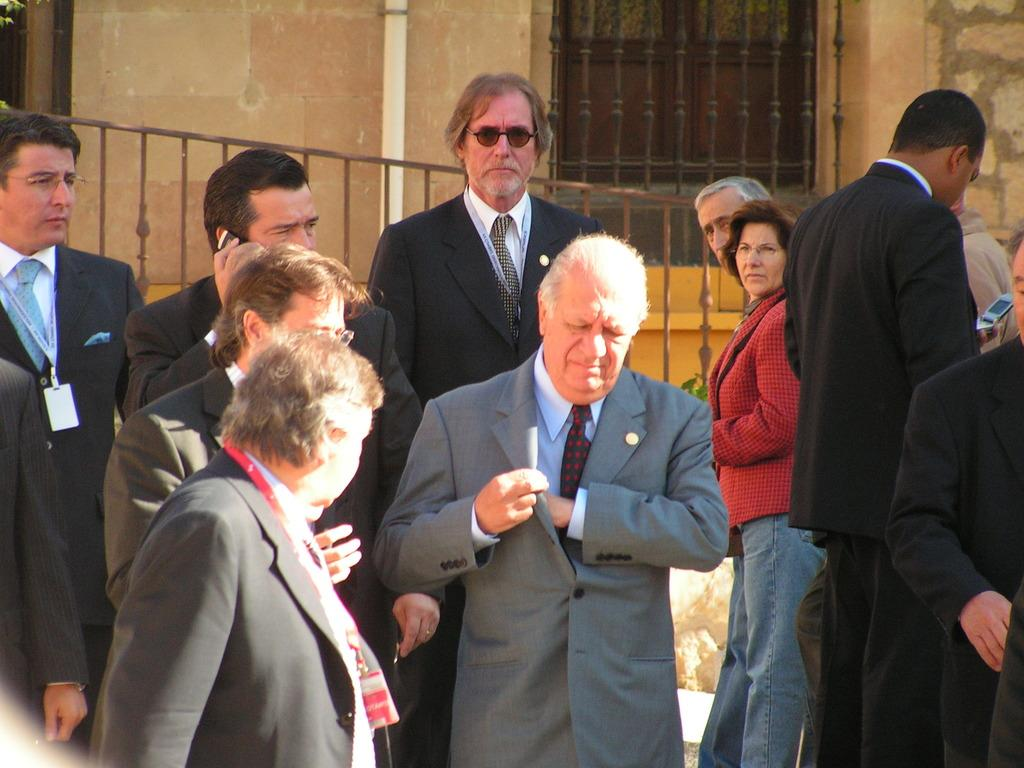How many people are in the image? There is a group of people in the image. What can be seen in the image besides the people? There is a fence in the image. What is visible in the background of the image? There is a wall, a window, and a pipe in the background of the image. How many needles are being used by the people in the image? There is no mention of needles in the image, so it cannot be determined how many are being used. 